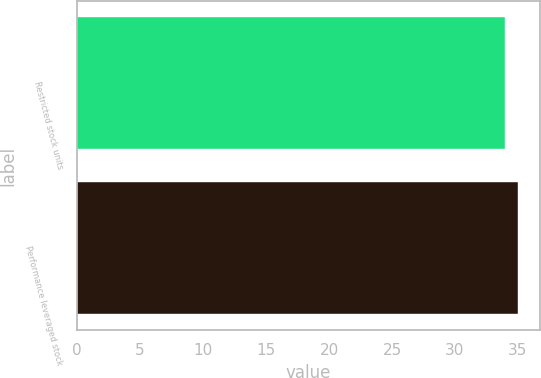Convert chart to OTSL. <chart><loc_0><loc_0><loc_500><loc_500><bar_chart><fcel>Restricted stock units<fcel>Performance leveraged stock<nl><fcel>34<fcel>35<nl></chart> 